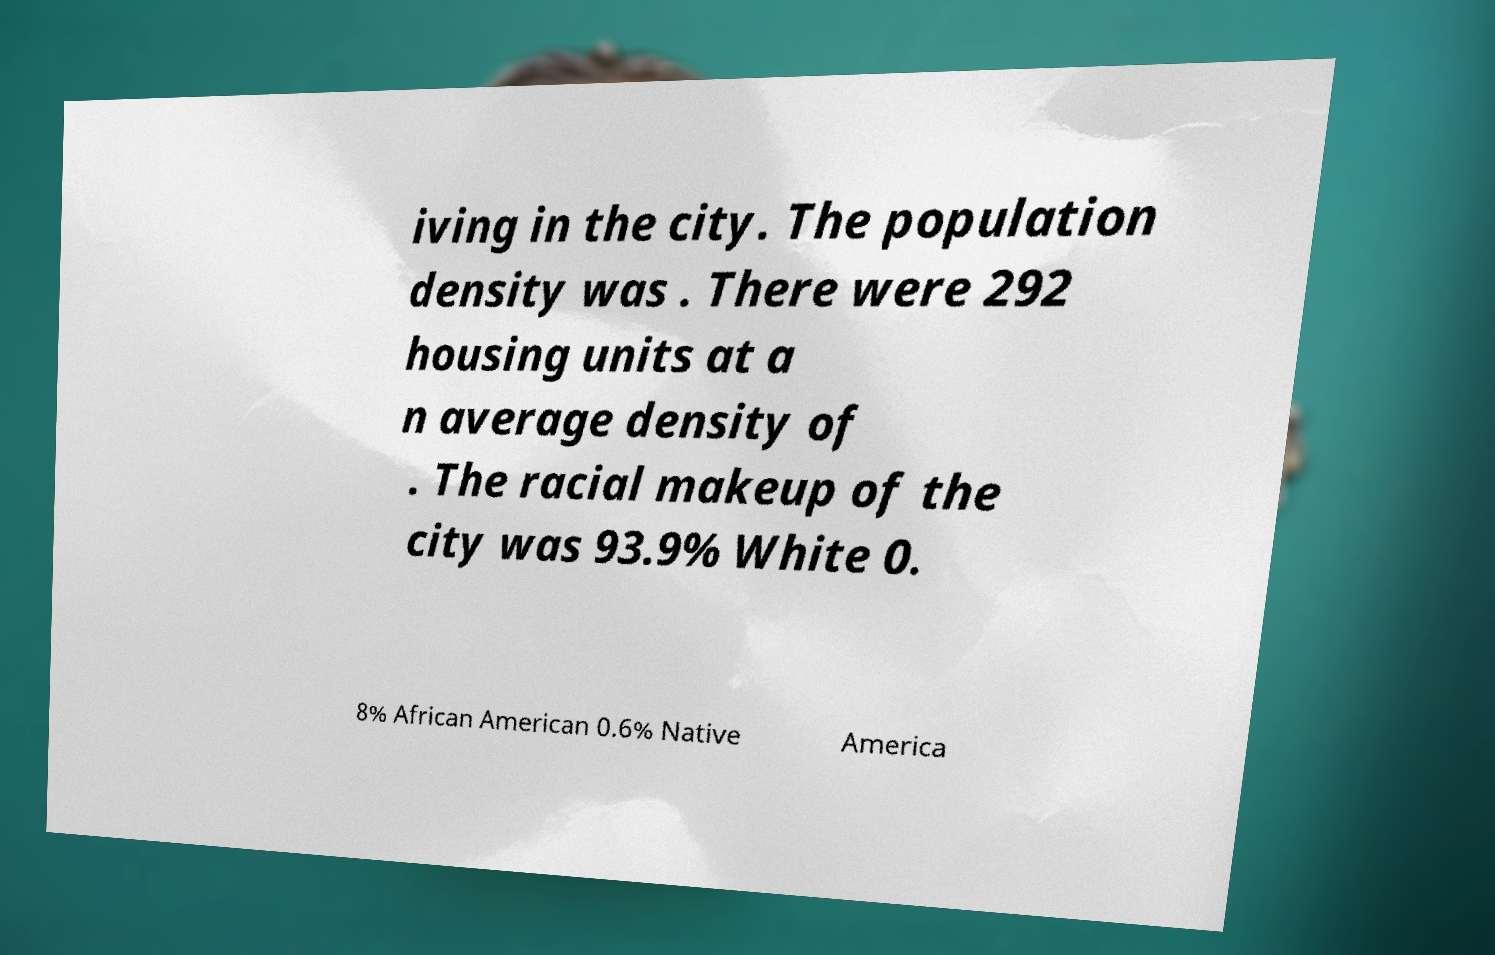Please read and relay the text visible in this image. What does it say? iving in the city. The population density was . There were 292 housing units at a n average density of . The racial makeup of the city was 93.9% White 0. 8% African American 0.6% Native America 